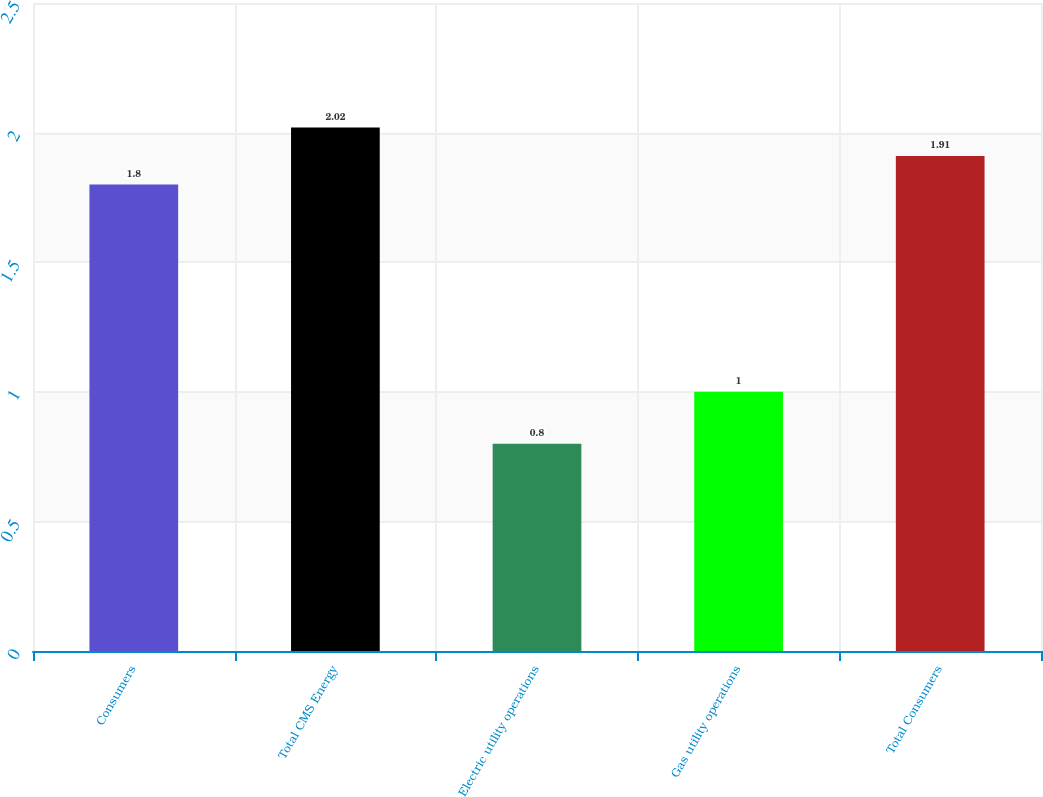Convert chart. <chart><loc_0><loc_0><loc_500><loc_500><bar_chart><fcel>Consumers<fcel>Total CMS Energy<fcel>Electric utility operations<fcel>Gas utility operations<fcel>Total Consumers<nl><fcel>1.8<fcel>2.02<fcel>0.8<fcel>1<fcel>1.91<nl></chart> 